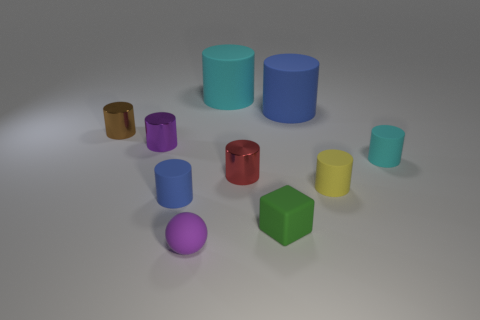Subtract all cyan cylinders. How many cylinders are left? 6 Subtract all tiny red cylinders. How many cylinders are left? 7 Subtract 5 cylinders. How many cylinders are left? 3 Subtract all yellow cylinders. Subtract all brown cubes. How many cylinders are left? 7 Subtract all cylinders. How many objects are left? 2 Add 3 small red things. How many small red things are left? 4 Add 4 big things. How many big things exist? 6 Subtract 0 yellow cubes. How many objects are left? 10 Subtract all small purple matte balls. Subtract all tiny red cylinders. How many objects are left? 8 